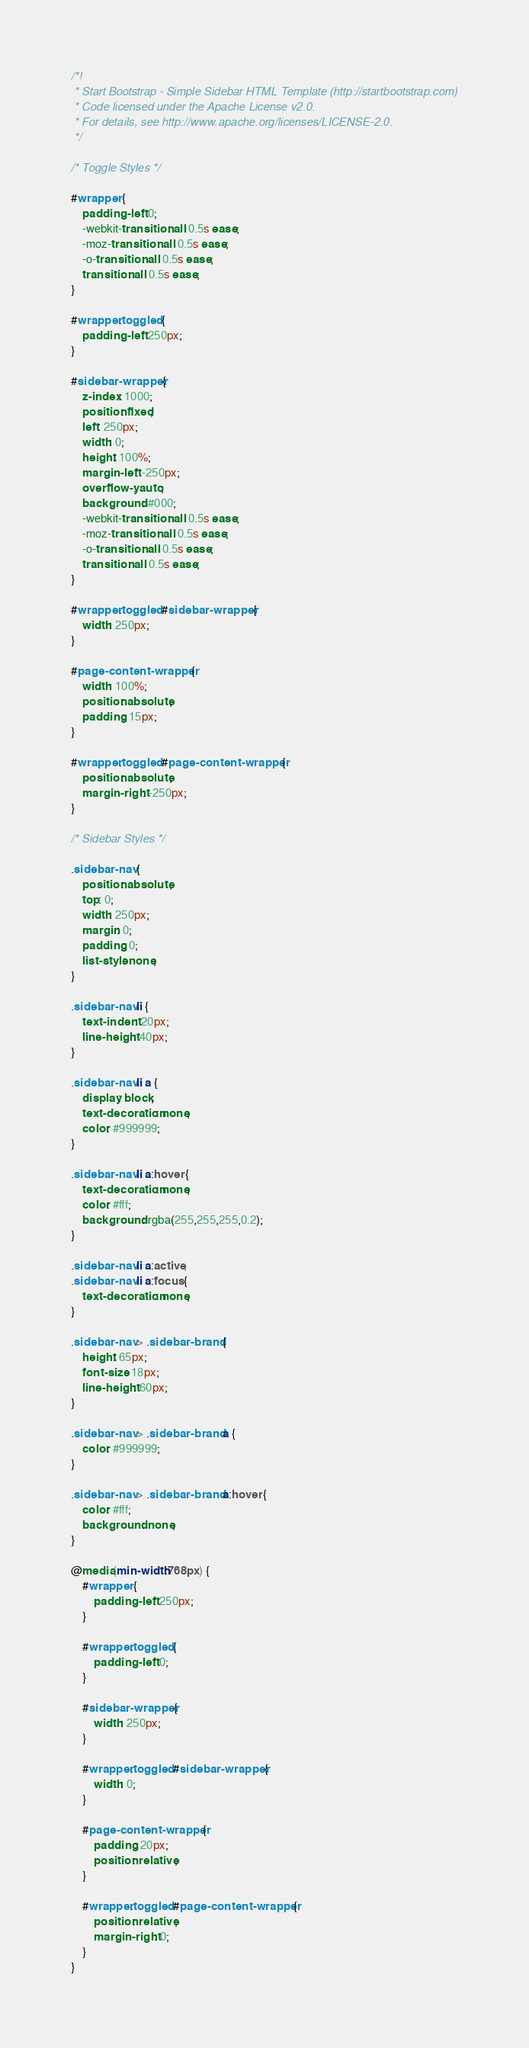<code> <loc_0><loc_0><loc_500><loc_500><_CSS_>/*!
 * Start Bootstrap - Simple Sidebar HTML Template (http://startbootstrap.com)
 * Code licensed under the Apache License v2.0.
 * For details, see http://www.apache.org/licenses/LICENSE-2.0.
 */

/* Toggle Styles */

#wrapper {
    padding-left: 0;
    -webkit-transition: all 0.5s ease;
    -moz-transition: all 0.5s ease;
    -o-transition: all 0.5s ease;
    transition: all 0.5s ease;
}

#wrapper.toggled {
    padding-left: 250px;
}

#sidebar-wrapper {
    z-index: 1000;
    position: fixed;
    left: 250px;
    width: 0;
    height: 100%;
    margin-left: -250px;
    overflow-y: auto;
    background: #000;
    -webkit-transition: all 0.5s ease;
    -moz-transition: all 0.5s ease;
    -o-transition: all 0.5s ease;
    transition: all 0.5s ease;
}

#wrapper.toggled #sidebar-wrapper {
    width: 250px;
}

#page-content-wrapper {
    width: 100%;
    position: absolute;
    padding: 15px;
}

#wrapper.toggled #page-content-wrapper {
    position: absolute;
    margin-right: -250px;
}

/* Sidebar Styles */

.sidebar-nav {
    position: absolute;
    top: 0;
    width: 250px;
    margin: 0;
    padding: 0;
    list-style: none;
}

.sidebar-nav li {
    text-indent: 20px;
    line-height: 40px;
}

.sidebar-nav li a {
    display: block;
    text-decoration: none;
    color: #999999;
}

.sidebar-nav li a:hover {
    text-decoration: none;
    color: #fff;
    background: rgba(255,255,255,0.2);
}

.sidebar-nav li a:active,
.sidebar-nav li a:focus {
    text-decoration: none;
}

.sidebar-nav > .sidebar-brand {
    height: 65px;
    font-size: 18px;
    line-height: 60px;
}

.sidebar-nav > .sidebar-brand a {
    color: #999999;
}

.sidebar-nav > .sidebar-brand a:hover {
    color: #fff;
    background: none;
}

@media(min-width:768px) {
    #wrapper {
        padding-left: 250px;
    }

    #wrapper.toggled {
        padding-left: 0;
    }

    #sidebar-wrapper {
        width: 250px;
    }

    #wrapper.toggled #sidebar-wrapper {
        width: 0;
    }

    #page-content-wrapper {
        padding: 20px;
        position: relative;
    }

    #wrapper.toggled #page-content-wrapper {
        position: relative;
        margin-right: 0;
    }
}
</code> 